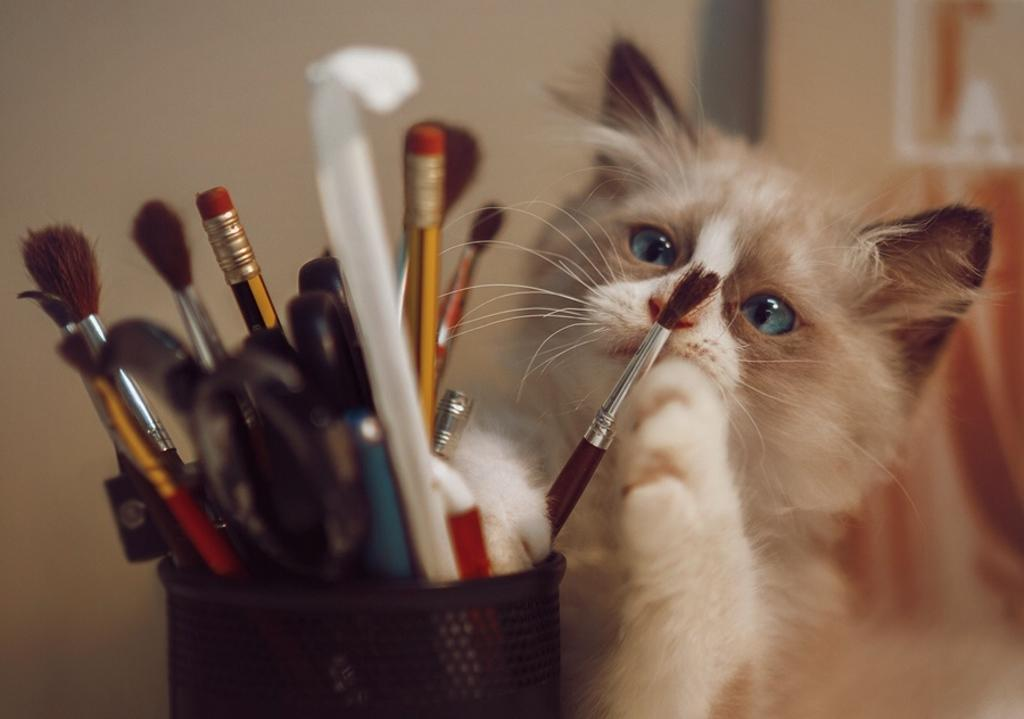What types of writing instruments are in the image? There are brushes and pencils in the image. What else can be found in the pen stand besides brushes and pencils? There are other things in the pen stand. Can you describe the background of the image? There is a cat visible in the background of the image. What type of prose is the cat reciting in the background of the image? There is no indication in the image that the cat is reciting any prose, as cats do not have the ability to speak or recite literature. 